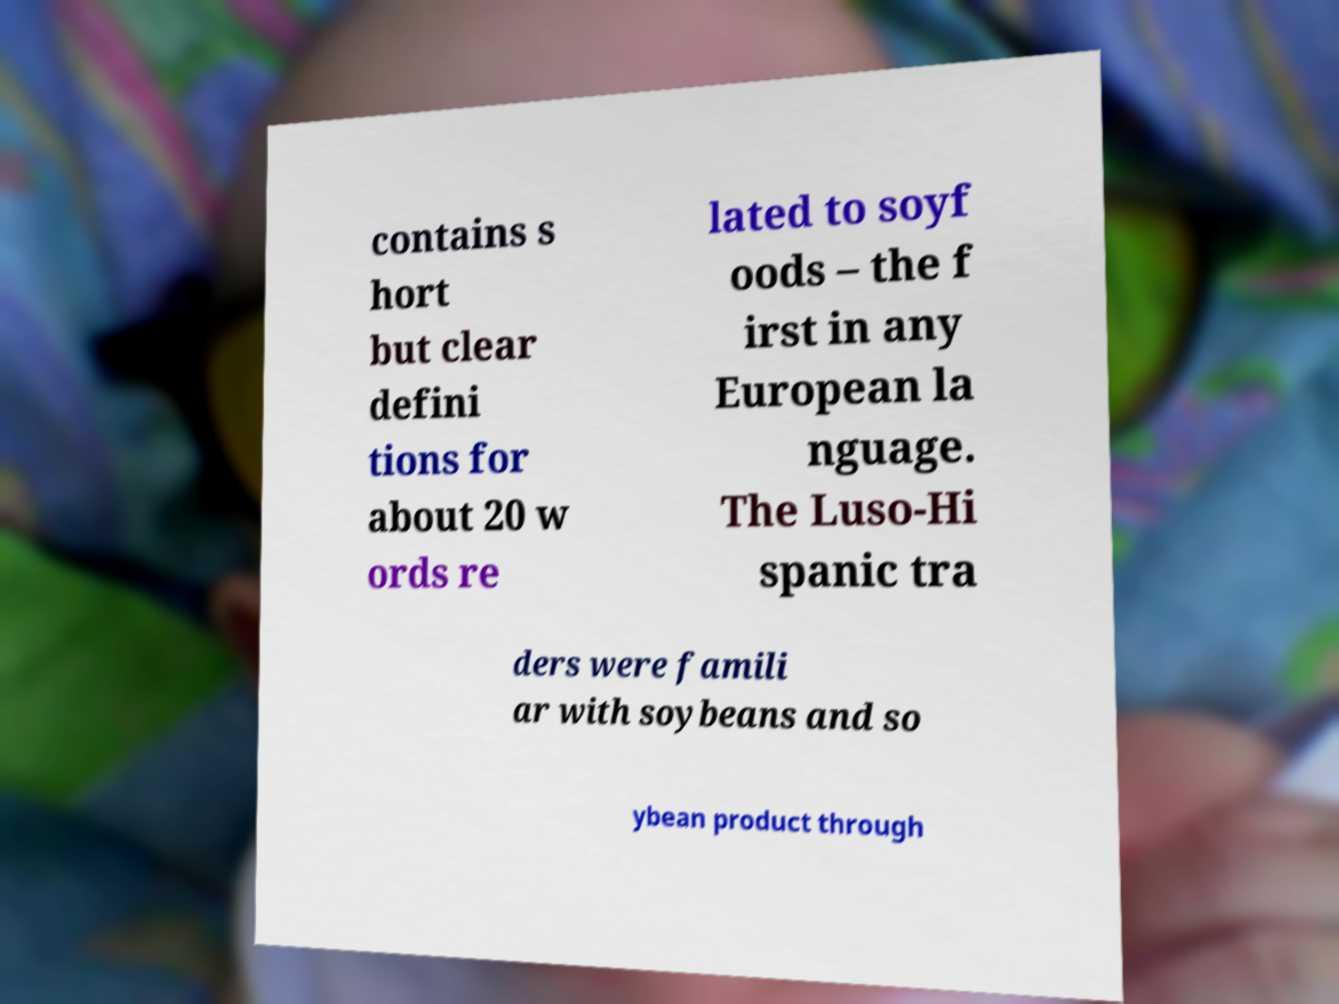I need the written content from this picture converted into text. Can you do that? contains s hort but clear defini tions for about 20 w ords re lated to soyf oods – the f irst in any European la nguage. The Luso-Hi spanic tra ders were famili ar with soybeans and so ybean product through 